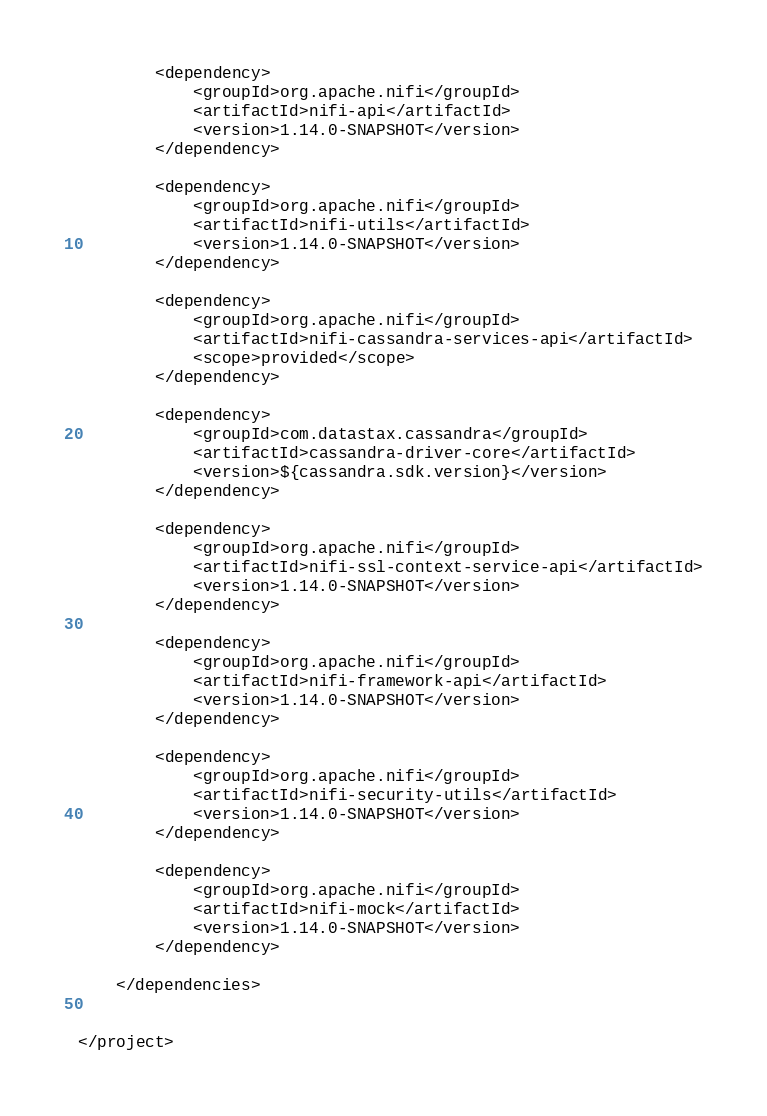Convert code to text. <code><loc_0><loc_0><loc_500><loc_500><_XML_>
        <dependency>
            <groupId>org.apache.nifi</groupId>
            <artifactId>nifi-api</artifactId>
            <version>1.14.0-SNAPSHOT</version>
        </dependency>

        <dependency>
            <groupId>org.apache.nifi</groupId>
            <artifactId>nifi-utils</artifactId>
            <version>1.14.0-SNAPSHOT</version>
        </dependency>

        <dependency>
            <groupId>org.apache.nifi</groupId>
            <artifactId>nifi-cassandra-services-api</artifactId>
            <scope>provided</scope>
        </dependency>

        <dependency>
            <groupId>com.datastax.cassandra</groupId>
            <artifactId>cassandra-driver-core</artifactId>
            <version>${cassandra.sdk.version}</version>
        </dependency>

        <dependency>
            <groupId>org.apache.nifi</groupId>
            <artifactId>nifi-ssl-context-service-api</artifactId>
            <version>1.14.0-SNAPSHOT</version>
        </dependency>

        <dependency>
            <groupId>org.apache.nifi</groupId>
            <artifactId>nifi-framework-api</artifactId>
            <version>1.14.0-SNAPSHOT</version>
        </dependency>

        <dependency>
            <groupId>org.apache.nifi</groupId>
            <artifactId>nifi-security-utils</artifactId>
            <version>1.14.0-SNAPSHOT</version>
        </dependency>

        <dependency>
            <groupId>org.apache.nifi</groupId>
            <artifactId>nifi-mock</artifactId>
            <version>1.14.0-SNAPSHOT</version>
        </dependency>

    </dependencies>


</project></code> 